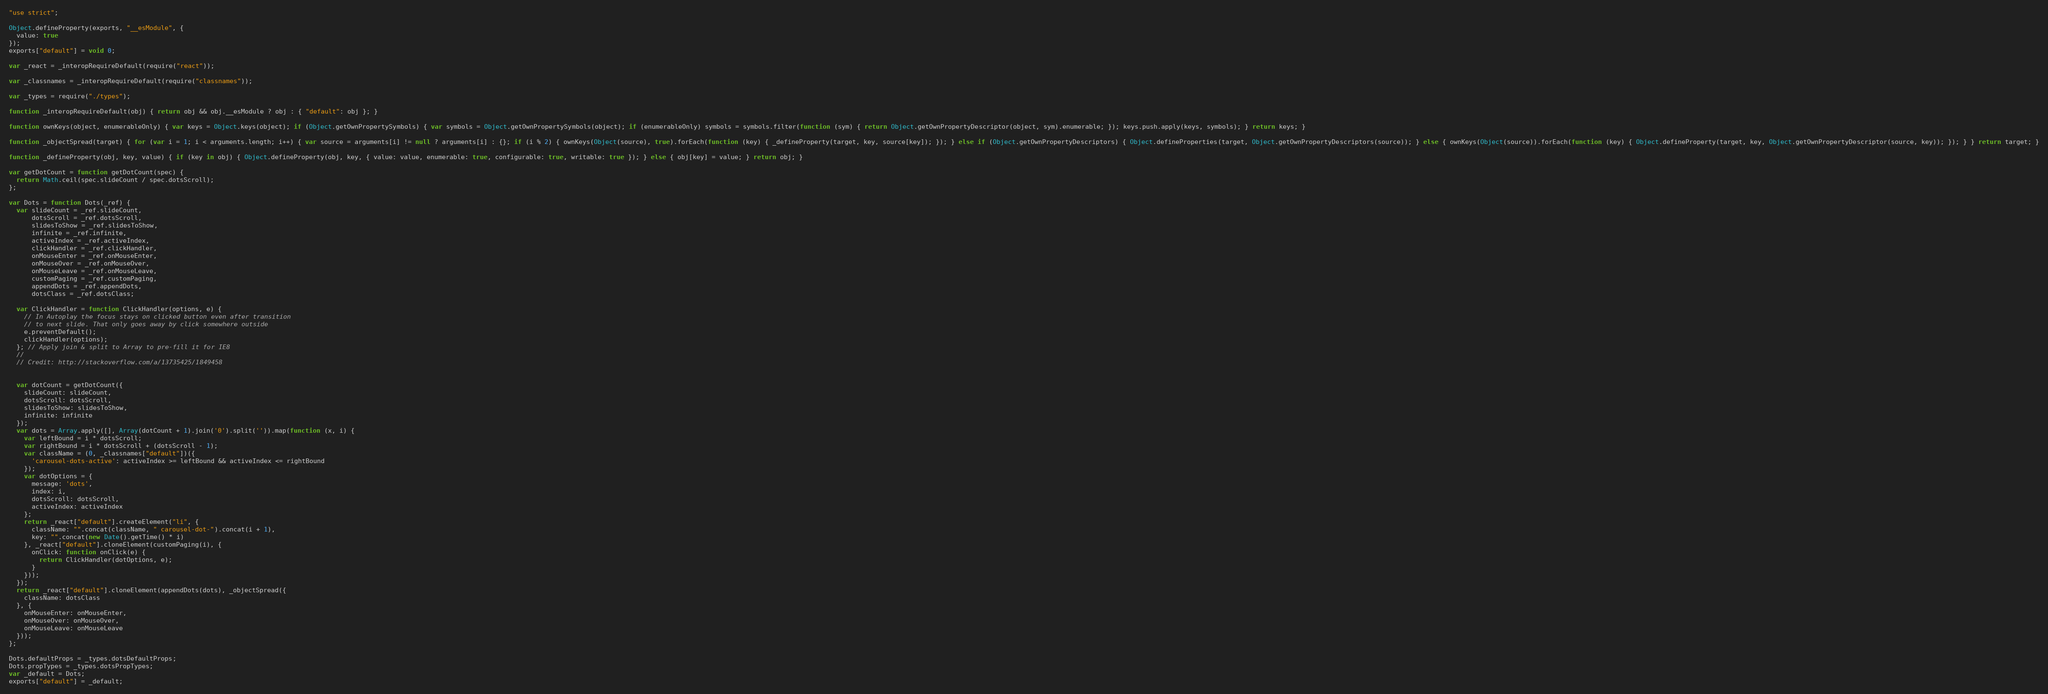<code> <loc_0><loc_0><loc_500><loc_500><_JavaScript_>"use strict";

Object.defineProperty(exports, "__esModule", {
  value: true
});
exports["default"] = void 0;

var _react = _interopRequireDefault(require("react"));

var _classnames = _interopRequireDefault(require("classnames"));

var _types = require("./types");

function _interopRequireDefault(obj) { return obj && obj.__esModule ? obj : { "default": obj }; }

function ownKeys(object, enumerableOnly) { var keys = Object.keys(object); if (Object.getOwnPropertySymbols) { var symbols = Object.getOwnPropertySymbols(object); if (enumerableOnly) symbols = symbols.filter(function (sym) { return Object.getOwnPropertyDescriptor(object, sym).enumerable; }); keys.push.apply(keys, symbols); } return keys; }

function _objectSpread(target) { for (var i = 1; i < arguments.length; i++) { var source = arguments[i] != null ? arguments[i] : {}; if (i % 2) { ownKeys(Object(source), true).forEach(function (key) { _defineProperty(target, key, source[key]); }); } else if (Object.getOwnPropertyDescriptors) { Object.defineProperties(target, Object.getOwnPropertyDescriptors(source)); } else { ownKeys(Object(source)).forEach(function (key) { Object.defineProperty(target, key, Object.getOwnPropertyDescriptor(source, key)); }); } } return target; }

function _defineProperty(obj, key, value) { if (key in obj) { Object.defineProperty(obj, key, { value: value, enumerable: true, configurable: true, writable: true }); } else { obj[key] = value; } return obj; }

var getDotCount = function getDotCount(spec) {
  return Math.ceil(spec.slideCount / spec.dotsScroll);
};

var Dots = function Dots(_ref) {
  var slideCount = _ref.slideCount,
      dotsScroll = _ref.dotsScroll,
      slidesToShow = _ref.slidesToShow,
      infinite = _ref.infinite,
      activeIndex = _ref.activeIndex,
      clickHandler = _ref.clickHandler,
      onMouseEnter = _ref.onMouseEnter,
      onMouseOver = _ref.onMouseOver,
      onMouseLeave = _ref.onMouseLeave,
      customPaging = _ref.customPaging,
      appendDots = _ref.appendDots,
      dotsClass = _ref.dotsClass;

  var ClickHandler = function ClickHandler(options, e) {
    // In Autoplay the focus stays on clicked button even after transition
    // to next slide. That only goes away by click somewhere outside
    e.preventDefault();
    clickHandler(options);
  }; // Apply join & split to Array to pre-fill it for IE8
  //
  // Credit: http://stackoverflow.com/a/13735425/1849458


  var dotCount = getDotCount({
    slideCount: slideCount,
    dotsScroll: dotsScroll,
    slidesToShow: slidesToShow,
    infinite: infinite
  });
  var dots = Array.apply([], Array(dotCount + 1).join('0').split('')).map(function (x, i) {
    var leftBound = i * dotsScroll;
    var rightBound = i * dotsScroll + (dotsScroll - 1);
    var className = (0, _classnames["default"])({
      'carousel-dots-active': activeIndex >= leftBound && activeIndex <= rightBound
    });
    var dotOptions = {
      message: 'dots',
      index: i,
      dotsScroll: dotsScroll,
      activeIndex: activeIndex
    };
    return _react["default"].createElement("li", {
      className: "".concat(className, " carousel-dot-").concat(i + 1),
      key: "".concat(new Date().getTime() * i)
    }, _react["default"].cloneElement(customPaging(i), {
      onClick: function onClick(e) {
        return ClickHandler(dotOptions, e);
      }
    }));
  });
  return _react["default"].cloneElement(appendDots(dots), _objectSpread({
    className: dotsClass
  }, {
    onMouseEnter: onMouseEnter,
    onMouseOver: onMouseOver,
    onMouseLeave: onMouseLeave
  }));
};

Dots.defaultProps = _types.dotsDefaultProps;
Dots.propTypes = _types.dotsPropTypes;
var _default = Dots;
exports["default"] = _default;</code> 